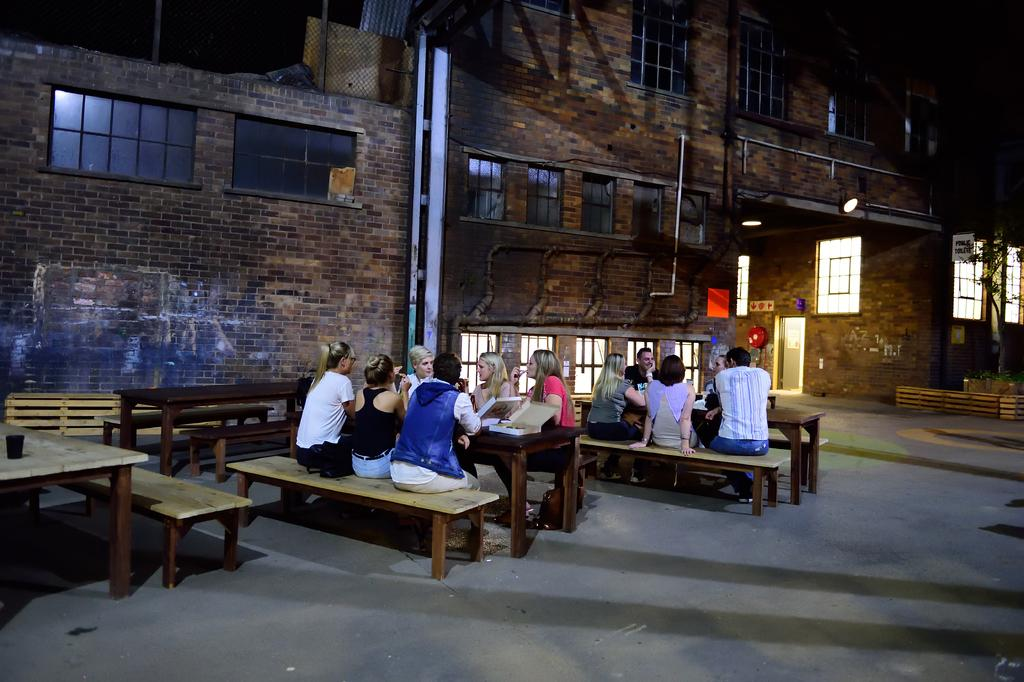What are the people in the image doing? The people in the image are sitting on a bench. What other object is present in the image besides the bench? There is a table in the image. What can be seen in the background of the image? There is a building beside the bench and table in the image. Where is the nest located in the image? There is no nest present in the image. What type of tin is being used by the people sitting on the bench? There is no tin present in the image. 